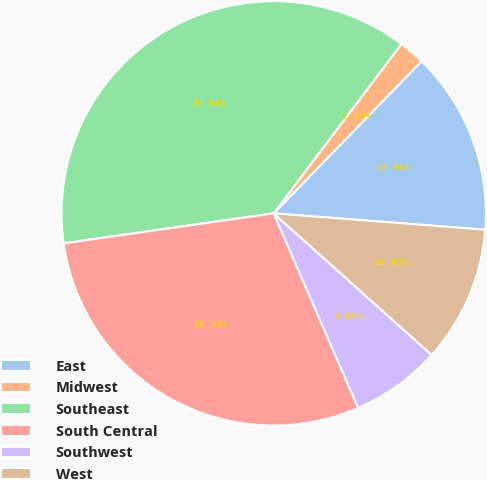Convert chart. <chart><loc_0><loc_0><loc_500><loc_500><pie_chart><fcel>East<fcel>Midwest<fcel>Southeast<fcel>South Central<fcel>Southwest<fcel>West<nl><fcel>13.96%<fcel>1.99%<fcel>37.55%<fcel>29.27%<fcel>6.85%<fcel>10.4%<nl></chart> 